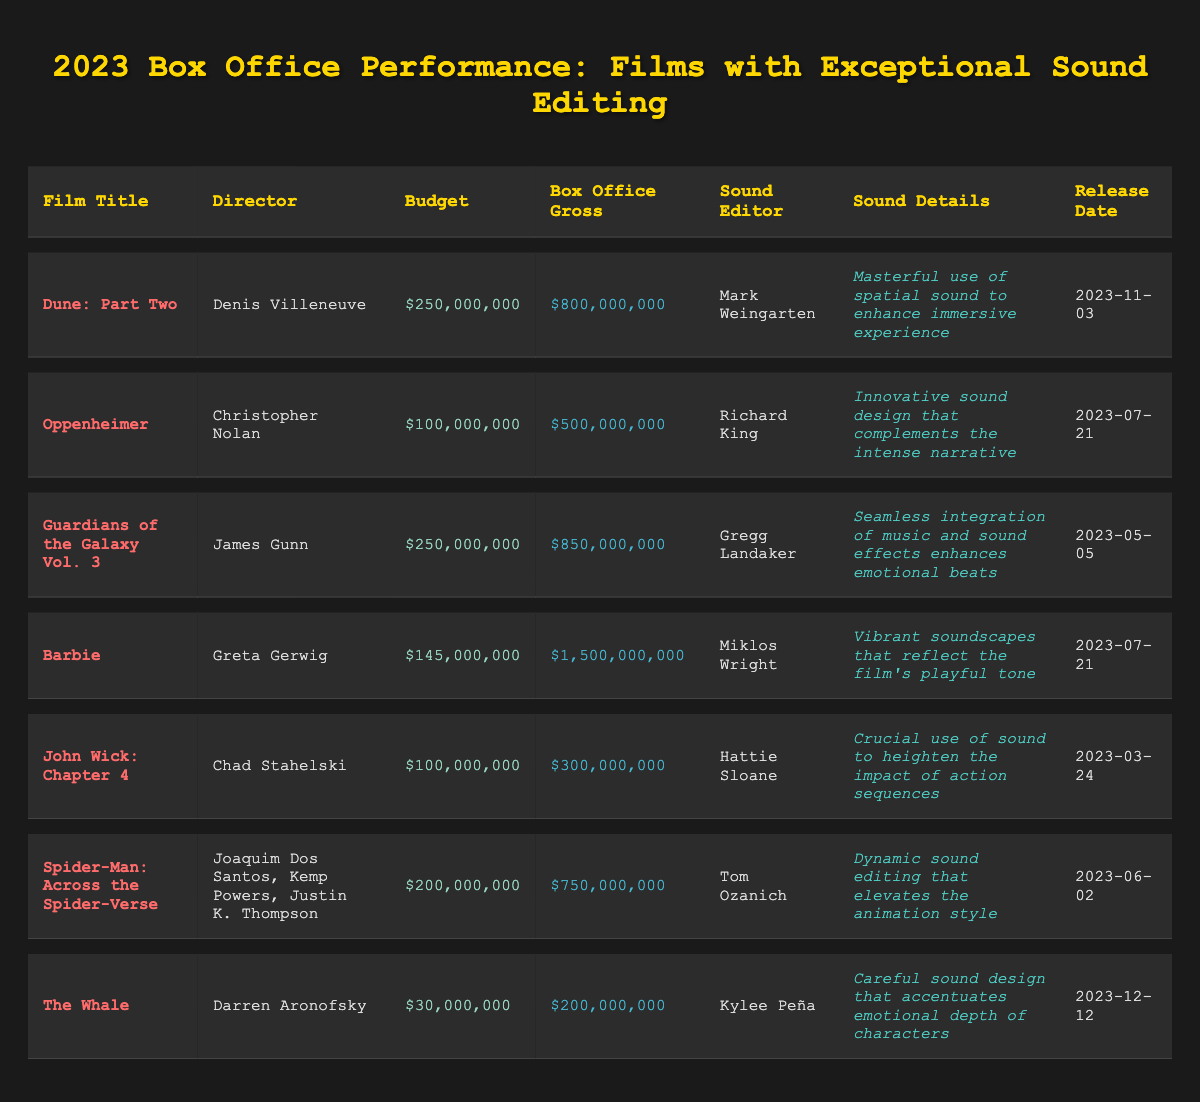What is the highest box office gross among the films listed? The box office gross values are $800,000,000 for "Dune: Part Two," $500,000,000 for "Oppenheimer," $850,000,000 for "Guardians of the Galaxy Vol. 3," $1,500,000,000 for "Barbie," $300,000,000 for "John Wick: Chapter 4," $750,000,000 for "Spider-Man: Across the Spider-Verse," and $200,000,000 for "The Whale." The highest is $1,500,000,000 for "Barbie."
Answer: $1,500,000,000 Which film had the smallest budget? The budgets for the films are $250,000,000 for "Dune: Part Two," $100,000,000 for "Oppenheimer," $250,000,000 for "Guardians of the Galaxy Vol. 3," $145,000,000 for "Barbie," $100,000,000 for "John Wick: Chapter 4," $200,000,000 for "Spider-Man: Across the Spider-Verse," and $30,000,000 for "The Whale." The smallest budget is $30,000,000 for "The Whale."
Answer: $30,000,000 How many films were released on July 21, 2023? The table shows that two films, "Oppenheimer" and "Barbie," were released on July 21, 2023.
Answer: 2 What is the average box office gross of the films listed? The total box office gross is $800,000,000 + $500,000,000 + $850,000,000 + $1,500,000,000 + $300,000,000 + $750,000,000 + $200,000,000 = $4,100,000,000. There are 7 films, so the average is $4,100,000,000 / 7 = approximately $585,714,286.
Answer: $585,714,286 Which film had the most innovative sound details according to the table? "Oppenheimer" is described as having "innovative sound design that complements the intense narrative," making it the film with the most innovative sound details.
Answer: Oppenheimer Did any of the films listed exceed their budget significantly based on their box office grosses? "Barbie" had a budget of $145,000,000 and grossed $1,500,000,000, which is significantly more than its budget. The same applies to "Guardians of the Galaxy Vol. 3" ($250,000,000 budget, $850,000,000 gross) and "Dune: Part Two" ($250,000,000 budget, $800,000,000 gross). Therefore, yes, all these films exceeded their budgets significantly.
Answer: Yes What is the difference in box office gross between "John Wick: Chapter 4" and "Dune: Part Two"? "John Wick: Chapter 4" grossed $300,000,000 and "Dune: Part Two" grossed $800,000,000. The difference is $800,000,000 - $300,000,000 = $500,000,000.
Answer: $500,000,000 Which film has the most recent release date? The release dates are "Dune: Part Two" on November 3, 2023, "Oppenheimer" on July 21, 2023, "Guardians of the Galaxy Vol. 3" on May 5, 2023, "Barbie" on July 21, 2023, "John Wick: Chapter 4" on March 24, 2023, "Spider-Man: Across the Spider-Verse" on June 2, 2023, and "The Whale" on December 12, 2023. "The Whale" has the most recent release date.
Answer: The Whale Which director is associated with the film that achieved the highest box office gross? The film that achieved the highest box office gross is "Barbie," which was directed by Greta Gerwig.
Answer: Greta Gerwig 